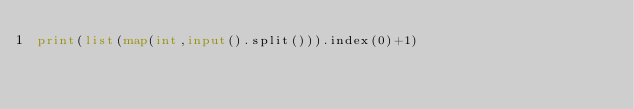Convert code to text. <code><loc_0><loc_0><loc_500><loc_500><_Python_>print(list(map(int,input().split())).index(0)+1)</code> 